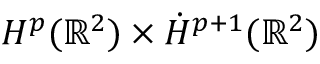<formula> <loc_0><loc_0><loc_500><loc_500>H ^ { p } ( \mathbb { R } ^ { 2 } ) \times \dot { H } ^ { p + 1 } ( \mathbb { R } ^ { 2 } )</formula> 